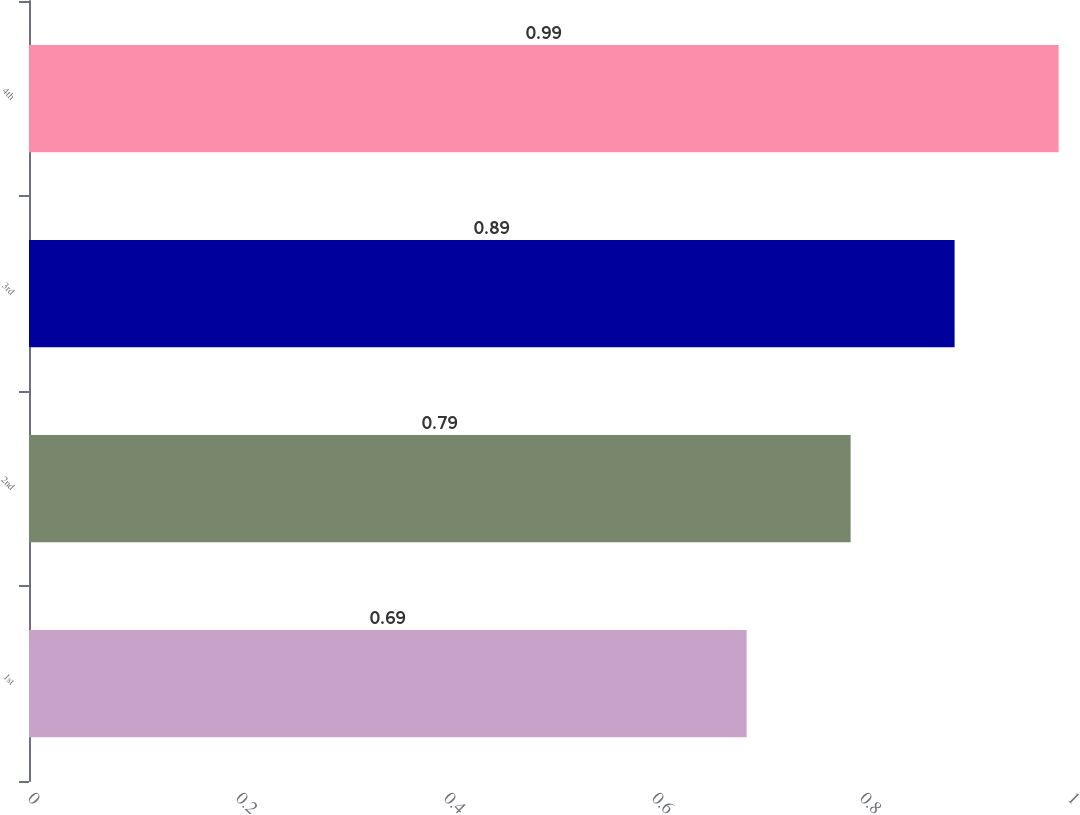<chart> <loc_0><loc_0><loc_500><loc_500><bar_chart><fcel>1st<fcel>2nd<fcel>3rd<fcel>4th<nl><fcel>0.69<fcel>0.79<fcel>0.89<fcel>0.99<nl></chart> 